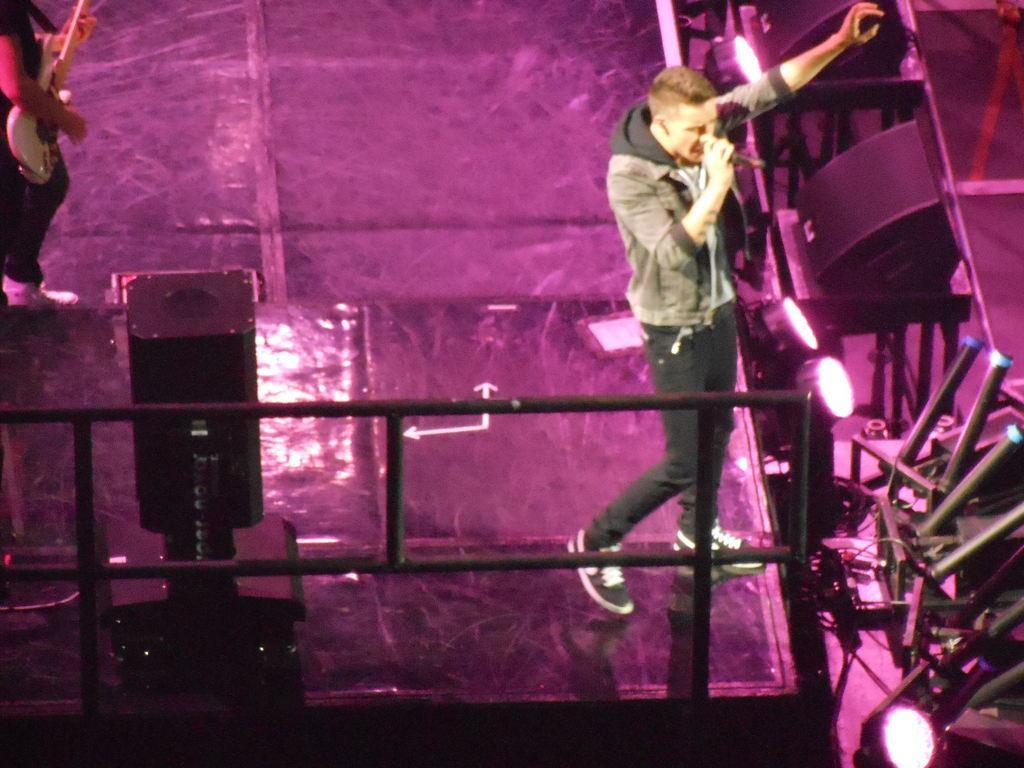Please provide a concise description of this image. In this image we can see a person standing on the right side and he is playing a guitar. There is a person standing on the top left and he is playing a guitar. 